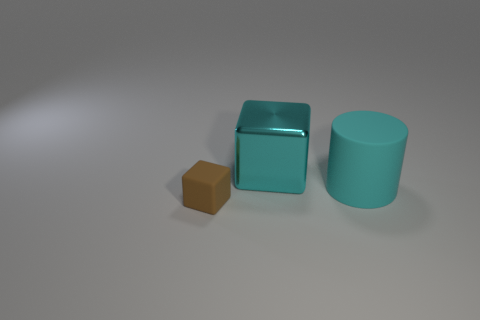Add 3 big blocks. How many objects exist? 6 Subtract all cyan blocks. How many blocks are left? 1 Subtract all gray spheres. How many brown cubes are left? 1 Subtract all cylinders. How many objects are left? 2 Subtract all gray cubes. Subtract all gray cylinders. How many cubes are left? 2 Add 1 small gray blocks. How many small gray blocks exist? 1 Subtract 1 cyan cylinders. How many objects are left? 2 Subtract 1 blocks. How many blocks are left? 1 Subtract all matte cylinders. Subtract all matte cylinders. How many objects are left? 1 Add 1 tiny brown rubber things. How many tiny brown rubber things are left? 2 